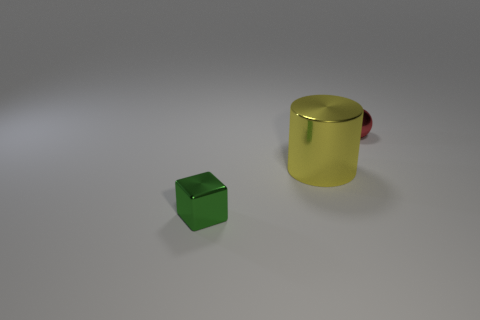Is there anything else that is the same size as the shiny cylinder?
Ensure brevity in your answer.  No. Are there fewer yellow cylinders that are in front of the green metal object than tiny shiny cubes left of the large cylinder?
Your response must be concise. Yes. How many other things are there of the same shape as the large thing?
Your response must be concise. 0. What number of yellow objects are either tiny metallic balls or large metal objects?
Make the answer very short. 1. There is a small object that is behind the metal object in front of the large yellow metallic cylinder; what is its shape?
Provide a short and direct response. Sphere. Are there any big brown spheres that have the same material as the yellow thing?
Make the answer very short. No. There is a tiny object that is behind the metallic object left of the large yellow shiny object; is there a small green shiny block that is left of it?
Make the answer very short. Yes. There is a small red shiny thing; are there any metallic things left of it?
Your answer should be compact. Yes. How many small red shiny things are to the right of the tiny object to the right of the block?
Offer a very short reply. 0. Is the size of the red sphere the same as the thing that is to the left of the big thing?
Offer a terse response. Yes. 